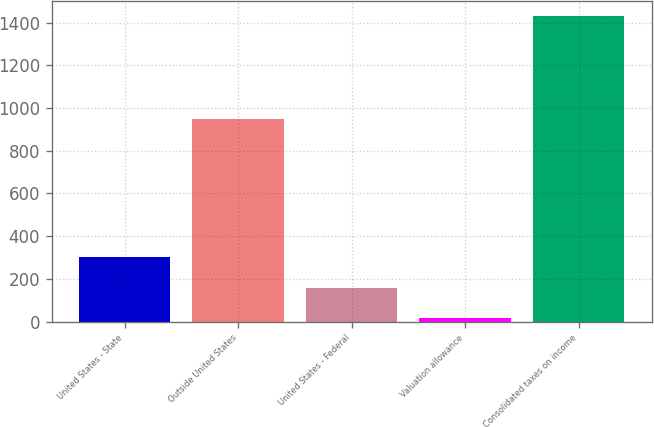Convert chart to OTSL. <chart><loc_0><loc_0><loc_500><loc_500><bar_chart><fcel>United States - State<fcel>Outside United States<fcel>United States - Federal<fcel>Valuation allowance<fcel>Consolidated taxes on income<nl><fcel>300.4<fcel>949<fcel>159.2<fcel>18<fcel>1430<nl></chart> 